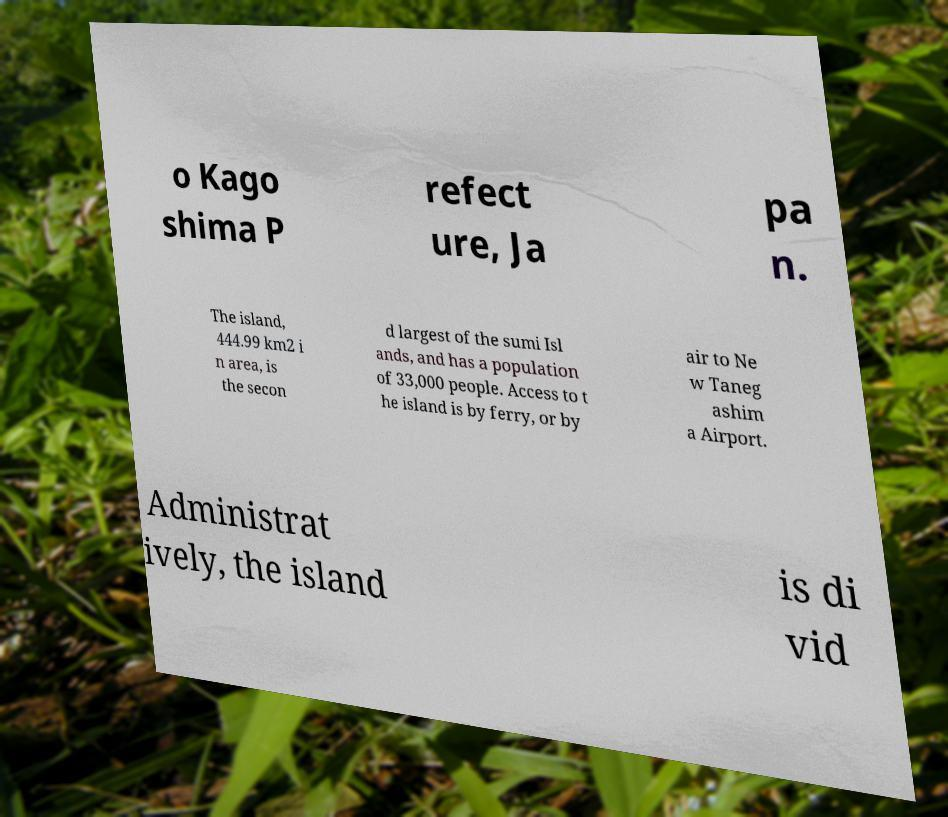Please read and relay the text visible in this image. What does it say? o Kago shima P refect ure, Ja pa n. The island, 444.99 km2 i n area, is the secon d largest of the sumi Isl ands, and has a population of 33,000 people. Access to t he island is by ferry, or by air to Ne w Taneg ashim a Airport. Administrat ively, the island is di vid 